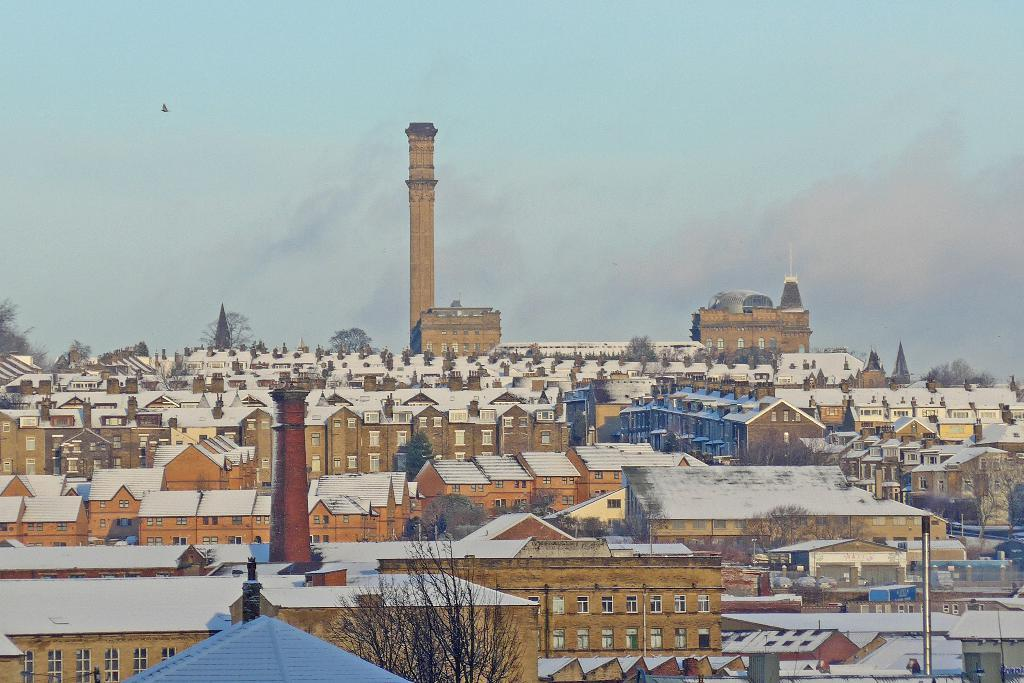What type of structures can be seen in the image? There are many buildings in the image. What colors are the buildings in the image? The buildings are in white and brown colors. What can be seen in the background of the image? There are trees and the sky visible in the background of the image. Can you tell me how many locks are on the doors of the buildings in the image? There is no information about locks on the doors of the buildings in the image. What type of cannon can be seen in the image? There is no cannon present in the image. 